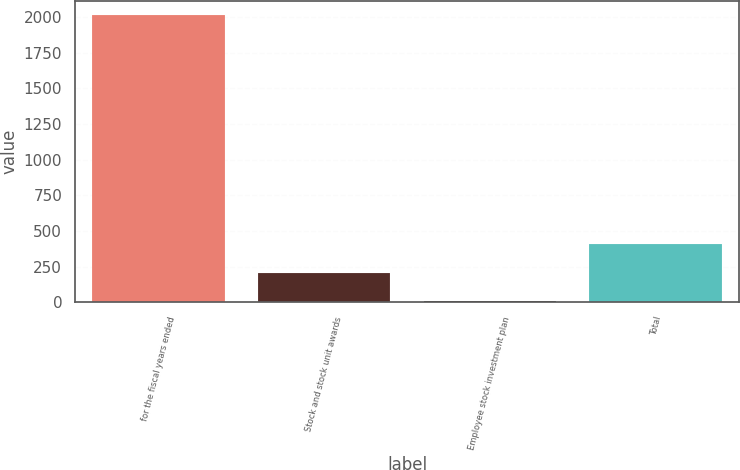<chart> <loc_0><loc_0><loc_500><loc_500><bar_chart><fcel>for the fiscal years ended<fcel>Stock and stock unit awards<fcel>Employee stock investment plan<fcel>Total<nl><fcel>2015<fcel>207.26<fcel>6.4<fcel>408.12<nl></chart> 